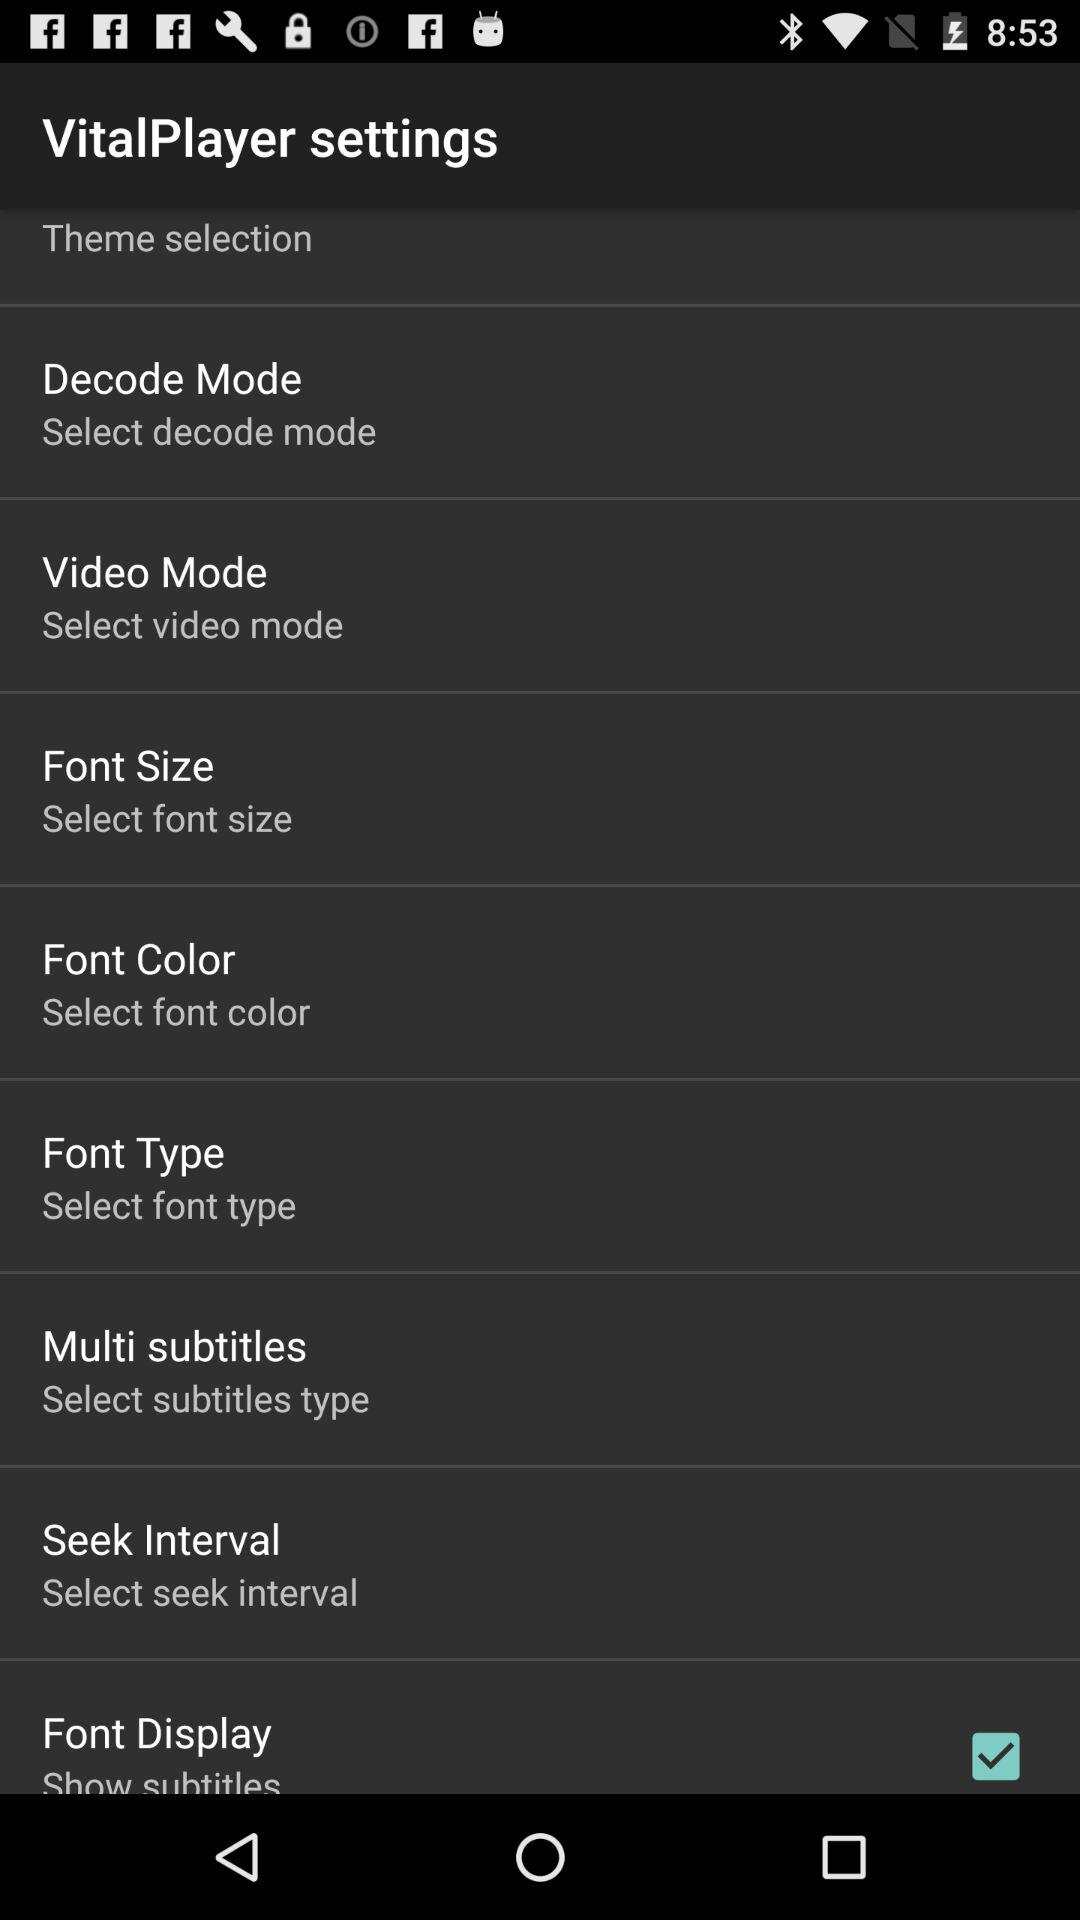What is the name of the application? The name of the application is "VitalPlayer". 